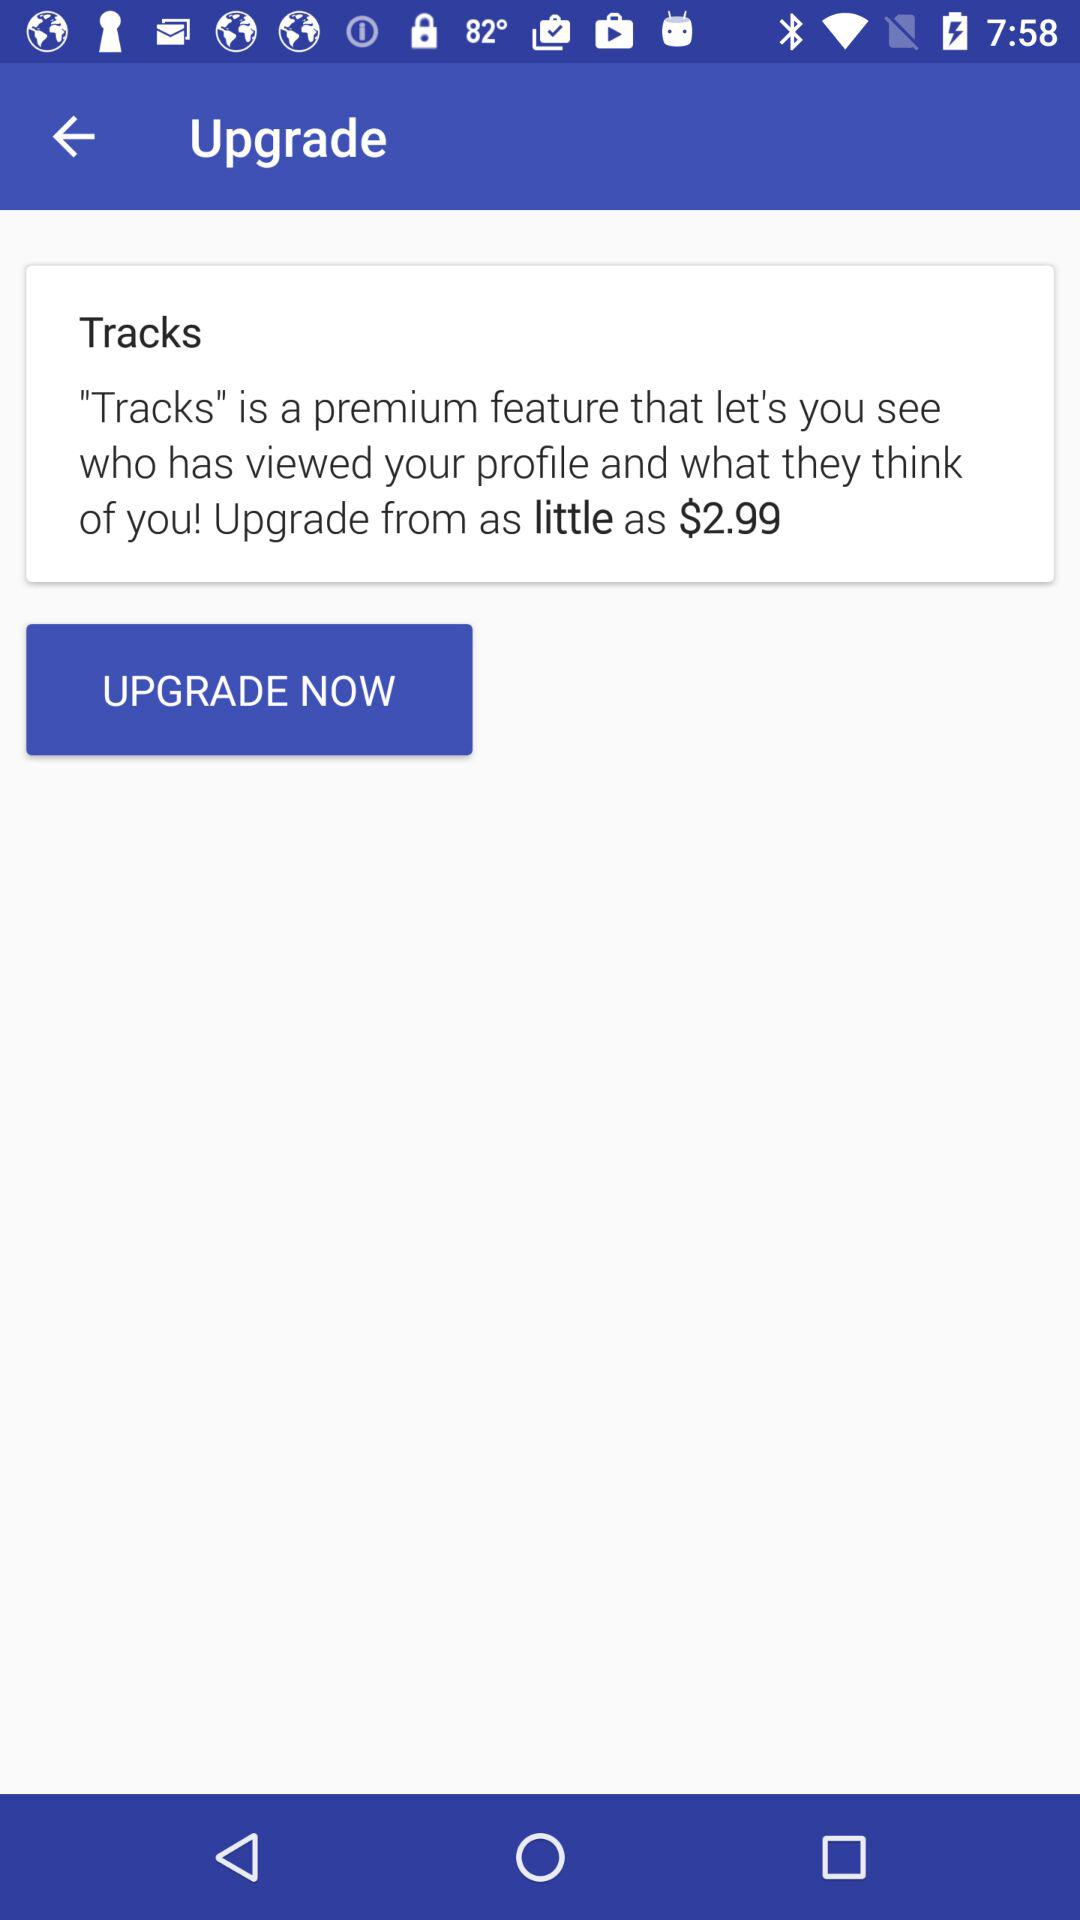How much is the charge to add "Tracks" feature? The charge is $2.99. 